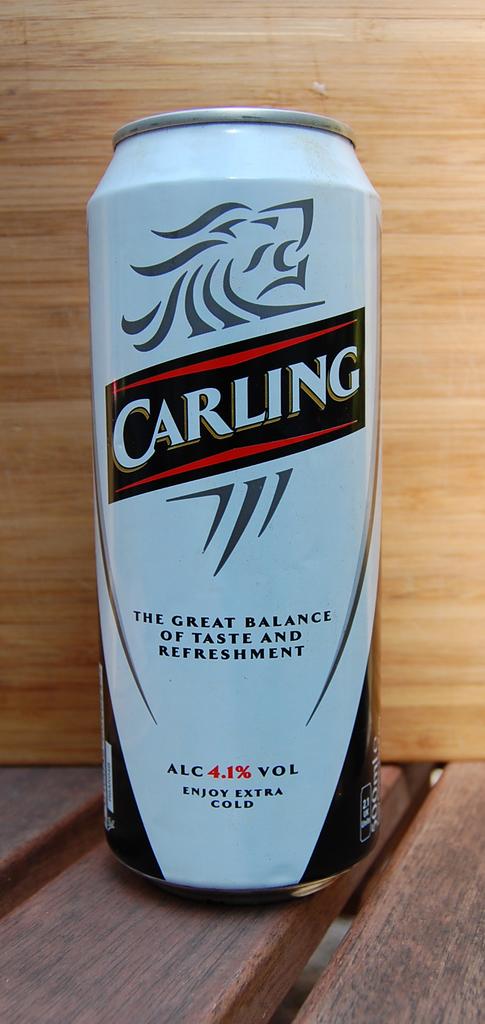How much alcohol is in this beverage?
Offer a terse response. 4.1%. 